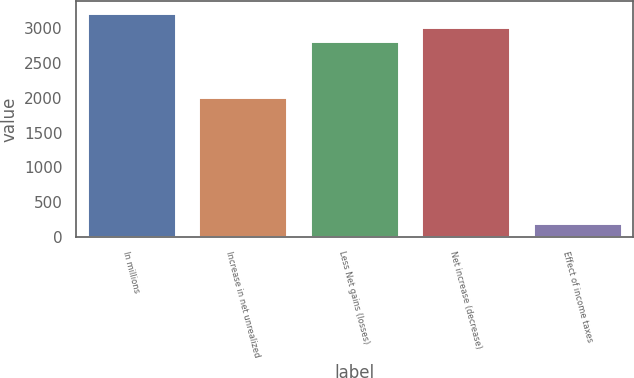Convert chart to OTSL. <chart><loc_0><loc_0><loc_500><loc_500><bar_chart><fcel>In millions<fcel>Increase in net unrealized<fcel>Less Net gains (losses)<fcel>Net increase (decrease)<fcel>Effect of income taxes<nl><fcel>3224.8<fcel>2017<fcel>2822.2<fcel>3023.5<fcel>205.3<nl></chart> 